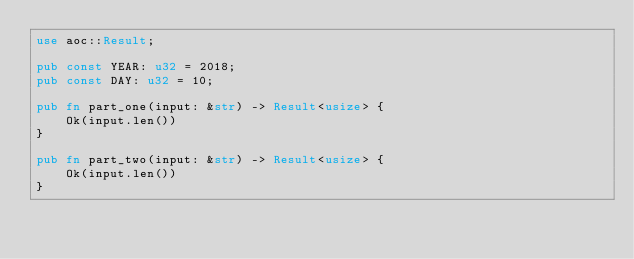Convert code to text. <code><loc_0><loc_0><loc_500><loc_500><_Rust_>use aoc::Result;

pub const YEAR: u32 = 2018;
pub const DAY: u32 = 10;

pub fn part_one(input: &str) -> Result<usize> {
    Ok(input.len())
}

pub fn part_two(input: &str) -> Result<usize> {
    Ok(input.len())
}
</code> 